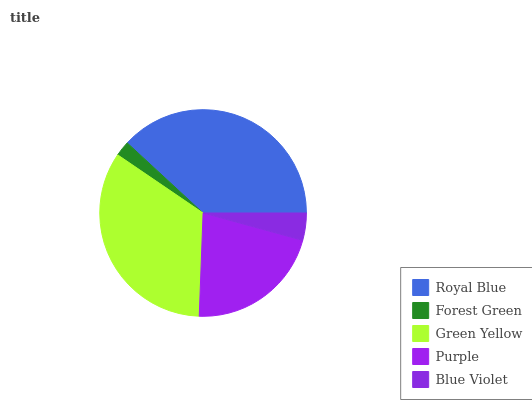Is Forest Green the minimum?
Answer yes or no. Yes. Is Royal Blue the maximum?
Answer yes or no. Yes. Is Green Yellow the minimum?
Answer yes or no. No. Is Green Yellow the maximum?
Answer yes or no. No. Is Green Yellow greater than Forest Green?
Answer yes or no. Yes. Is Forest Green less than Green Yellow?
Answer yes or no. Yes. Is Forest Green greater than Green Yellow?
Answer yes or no. No. Is Green Yellow less than Forest Green?
Answer yes or no. No. Is Purple the high median?
Answer yes or no. Yes. Is Purple the low median?
Answer yes or no. Yes. Is Green Yellow the high median?
Answer yes or no. No. Is Forest Green the low median?
Answer yes or no. No. 